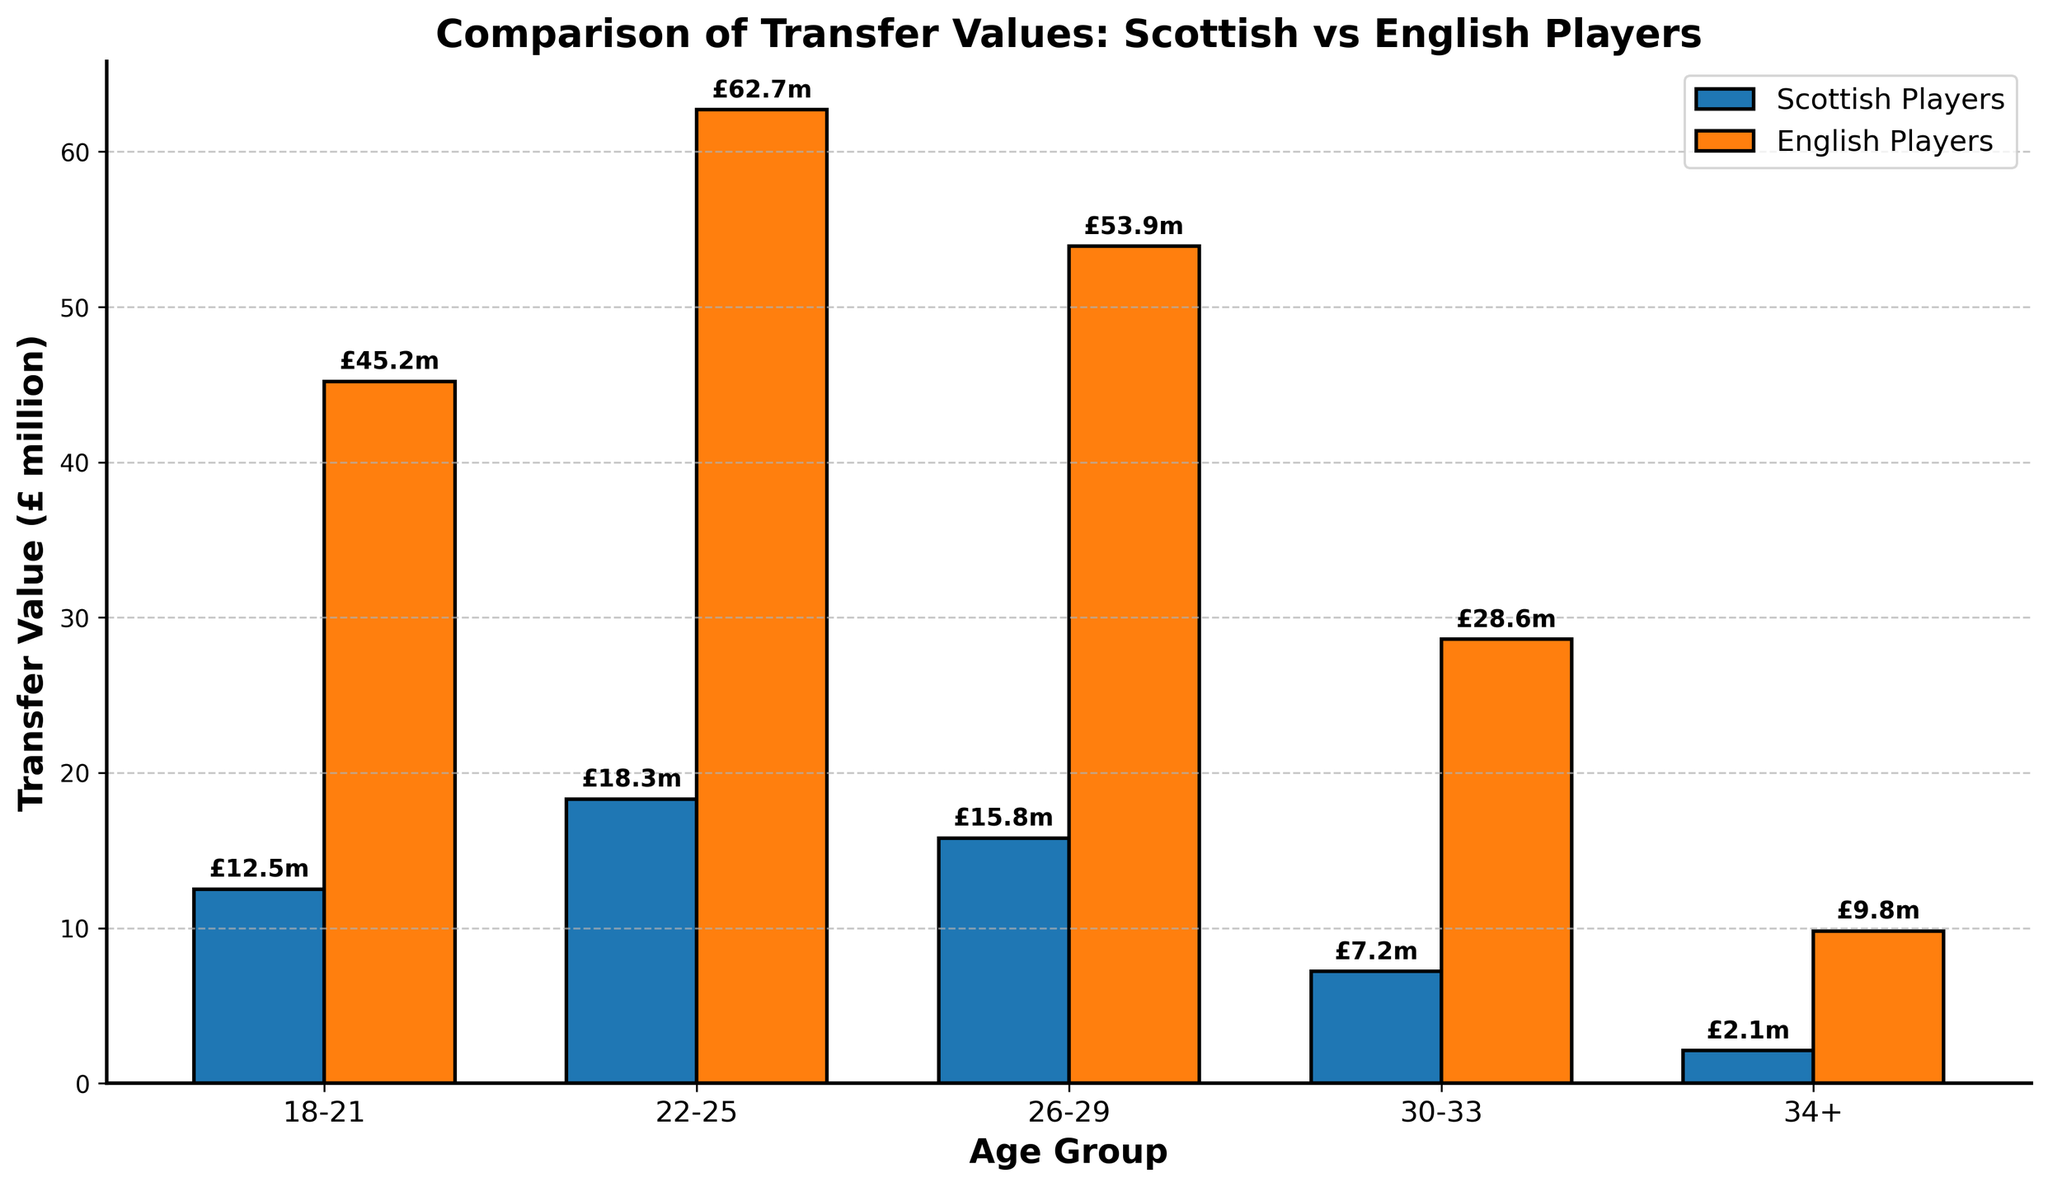What is the total transfer value for Scottish players in the age groups 18-21 and 22-25? Sum the values for Scottish players in the age groups 18-21 (£12.5 million) and 22-25 (£18.3 million). 12.5 + 18.3 = 30.8
Answer: 30.8 million How much more do English players aged 26-29 transfer for compared to Scottish players in the same age group? Subtract the transfer value of Scottish players aged 26-29 (£15.8 million) from that of English players in the same age group (£53.9 million). 53.9 - 15.8 = 38.1
Answer: 38.1 million Which age group has the lowest transfer value for Scottish players, and what is that value? Identify the smallest value in the Scottish players' transfer data. The lowest is £2.1 million for the age group 34+.
Answer: 34+, 2.1 million In the age group 22-25, what is the ratio of the transfer value for English players to that of Scottish players? Divide the transfer value for English players (£62.7 million) by the transfer value for Scottish players (£18.3 million) in the age group 22-25. 62.7 / 18.3 ≈ 3.43
Answer: 3.43 Which age group shows the biggest difference in transfer values between Scottish and English players? Calculate the differences for each age group and compare. 
18-21: 45.2 - 12.5 = 32.7
22-25: 62.7 - 18.3 = 44.4
26-29: 53.9 - 15.8 = 38.1
30-33: 28.6 - 7.2 = 21.4
34+: 9.8 - 2.1 = 7.7
The biggest difference is in the age group 22-25 with 44.4
Answer: 22-25, 44.4 million What is the average transfer value of English players across all age groups? Sum the transfer values for English players across all age groups and divide by the number of age groups. (45.2 + 62.7 + 53.9 + 28.6 + 9.8) / 5 = 200.2 / 5 = 40.04
Answer: 40.04 million Which age group has the highest transfer value for English players? Identify the largest value in the English players' transfer data. The highest is £62.7 million for the age group 22-25.
Answer: 22-25, 62.7 million If you add the transfer values for Scottish players in age groups 18-21, 26-29, and 30-33, how does it compare to the transfer value for English players in the age group 22-25? Sum the values for Scottish players in the age groups 18-21 (£12.5 million), 26-29 (£15.8 million), and 30-33 (£7.2 million), then compare it to the transfer value for English players in the age group 22-25 (£62.7 million). 12.5 + 15.8 + 7.2 = 35.5. 35.5 < 62.7
Answer: Less, 35.5 vs 62.7 By how much do the transfer values of English players in the age group 30-33 exceed those of Scottish players in the same age group? Subtract the transfer value of Scottish players aged 30-33 (£7.2 million) from that of English players in the same age group (£28.6 million). 28.6 - 7.2 = 21.4
Answer: 21.4 million What is the average transfer value difference between Scottish and English players across all age groups? Calculate the difference for each age group and find the average of these differences. 
18-21: 45.2 - 12.5 = 32.7
22-25: 62.7 - 18.3 = 44.4
26-29: 53.9 - 15.8 = 38.1
30-33: 28.6 - 7.2 = 21.4
34+: 9.8 - 2.1 = 7.7
(32.7 + 44.4 + 38.1 + 21.4 + 7.7) / 5 = 144.3 / 5 = 28.86
Answer: 28.86 million 